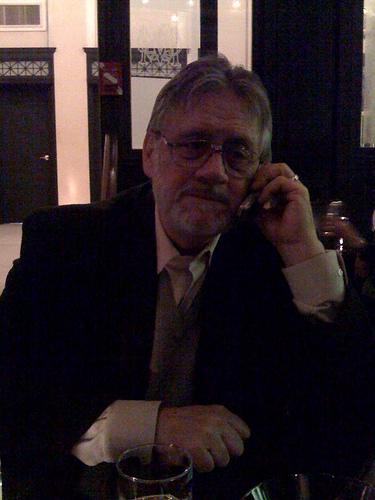What is the man holding in his hand?
Keep it brief. Phone. Is the man wearing a tie?
Write a very short answer. Yes. Is the man really talking on the phones?
Keep it brief. Yes. Is her wearing a vest?
Concise answer only. Yes. Is someone taking a picture?
Be succinct. No. How many phones are in the man's hands?
Keep it brief. 1. 